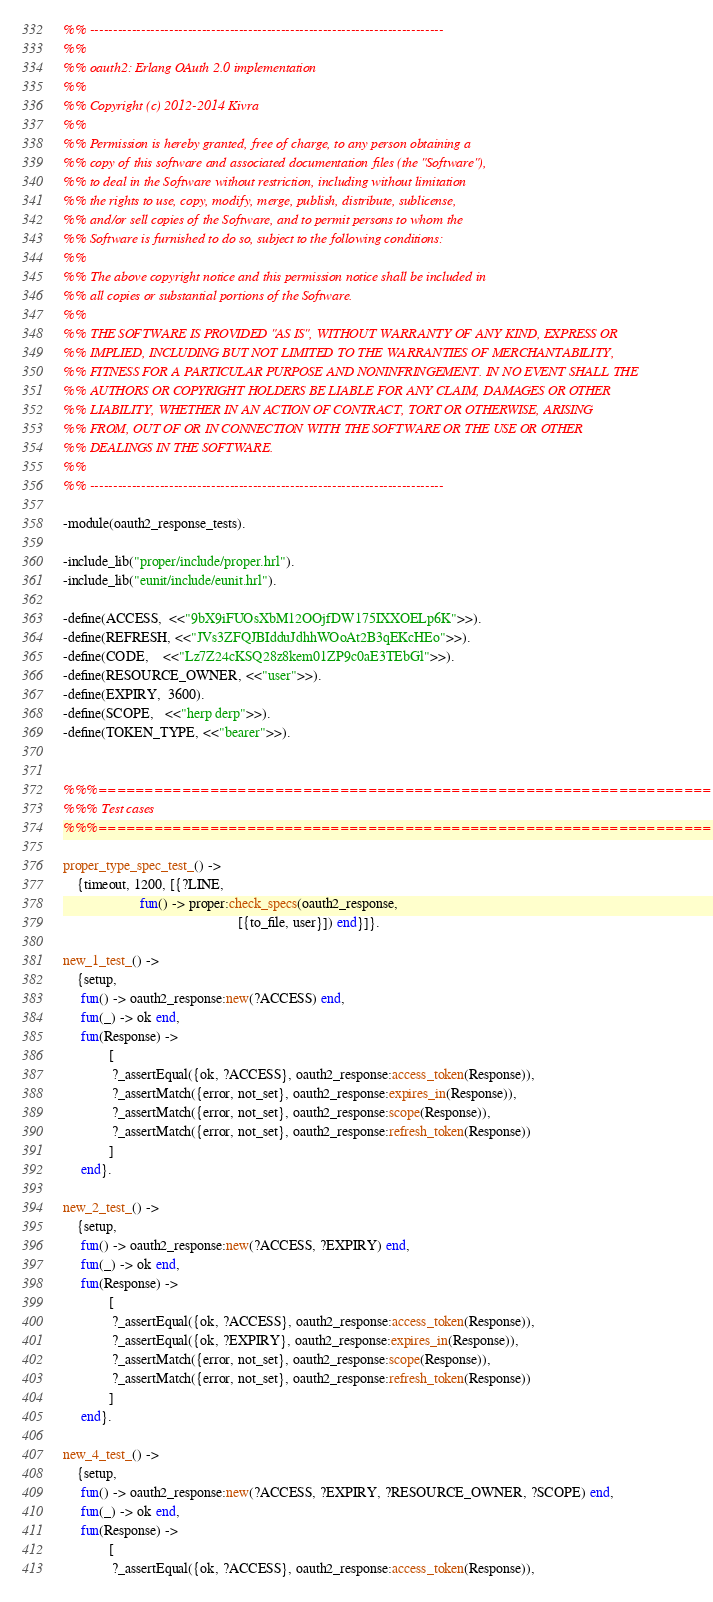<code> <loc_0><loc_0><loc_500><loc_500><_Erlang_>%% ----------------------------------------------------------------------------
%%
%% oauth2: Erlang OAuth 2.0 implementation
%%
%% Copyright (c) 2012-2014 Kivra
%%
%% Permission is hereby granted, free of charge, to any person obtaining a
%% copy of this software and associated documentation files (the "Software"),
%% to deal in the Software without restriction, including without limitation
%% the rights to use, copy, modify, merge, publish, distribute, sublicense,
%% and/or sell copies of the Software, and to permit persons to whom the
%% Software is furnished to do so, subject to the following conditions:
%%
%% The above copyright notice and this permission notice shall be included in
%% all copies or substantial portions of the Software.
%%
%% THE SOFTWARE IS PROVIDED "AS IS", WITHOUT WARRANTY OF ANY KIND, EXPRESS OR
%% IMPLIED, INCLUDING BUT NOT LIMITED TO THE WARRANTIES OF MERCHANTABILITY,
%% FITNESS FOR A PARTICULAR PURPOSE AND NONINFRINGEMENT. IN NO EVENT SHALL THE
%% AUTHORS OR COPYRIGHT HOLDERS BE LIABLE FOR ANY CLAIM, DAMAGES OR OTHER
%% LIABILITY, WHETHER IN AN ACTION OF CONTRACT, TORT OR OTHERWISE, ARISING
%% FROM, OUT OF OR IN CONNECTION WITH THE SOFTWARE OR THE USE OR OTHER
%% DEALINGS IN THE SOFTWARE.
%%
%% ----------------------------------------------------------------------------

-module(oauth2_response_tests).

-include_lib("proper/include/proper.hrl").
-include_lib("eunit/include/eunit.hrl").

-define(ACCESS,  <<"9bX9iFUOsXbM12OOjfDW175IXXOELp6K">>).
-define(REFRESH, <<"JVs3ZFQJBIdduJdhhWOoAt2B3qEKcHEo">>).
-define(CODE,    <<"Lz7Z24cKSQ28z8kem01ZP9c0aE3TEbGl">>).
-define(RESOURCE_OWNER, <<"user">>).
-define(EXPIRY,  3600).
-define(SCOPE,   <<"herp derp">>).
-define(TOKEN_TYPE, <<"bearer">>).


%%%===================================================================
%%% Test cases
%%%===================================================================

proper_type_spec_test_() ->
    {timeout, 1200, [{?LINE,
                      fun() -> proper:check_specs(oauth2_response,
                                                  [{to_file, user}]) end}]}.

new_1_test_() ->
    {setup,
     fun() -> oauth2_response:new(?ACCESS) end,
     fun(_) -> ok end,
     fun(Response) ->
             [
              ?_assertEqual({ok, ?ACCESS}, oauth2_response:access_token(Response)),
              ?_assertMatch({error, not_set}, oauth2_response:expires_in(Response)),
              ?_assertMatch({error, not_set}, oauth2_response:scope(Response)),
              ?_assertMatch({error, not_set}, oauth2_response:refresh_token(Response))
             ]
     end}.

new_2_test_() ->
    {setup,
     fun() -> oauth2_response:new(?ACCESS, ?EXPIRY) end,
     fun(_) -> ok end,
     fun(Response) ->
             [
              ?_assertEqual({ok, ?ACCESS}, oauth2_response:access_token(Response)),
              ?_assertEqual({ok, ?EXPIRY}, oauth2_response:expires_in(Response)),
              ?_assertMatch({error, not_set}, oauth2_response:scope(Response)),
              ?_assertMatch({error, not_set}, oauth2_response:refresh_token(Response))
             ]
     end}.

new_4_test_() ->
    {setup,
     fun() -> oauth2_response:new(?ACCESS, ?EXPIRY, ?RESOURCE_OWNER, ?SCOPE) end,
     fun(_) -> ok end,
     fun(Response) ->
             [
              ?_assertEqual({ok, ?ACCESS}, oauth2_response:access_token(Response)),</code> 